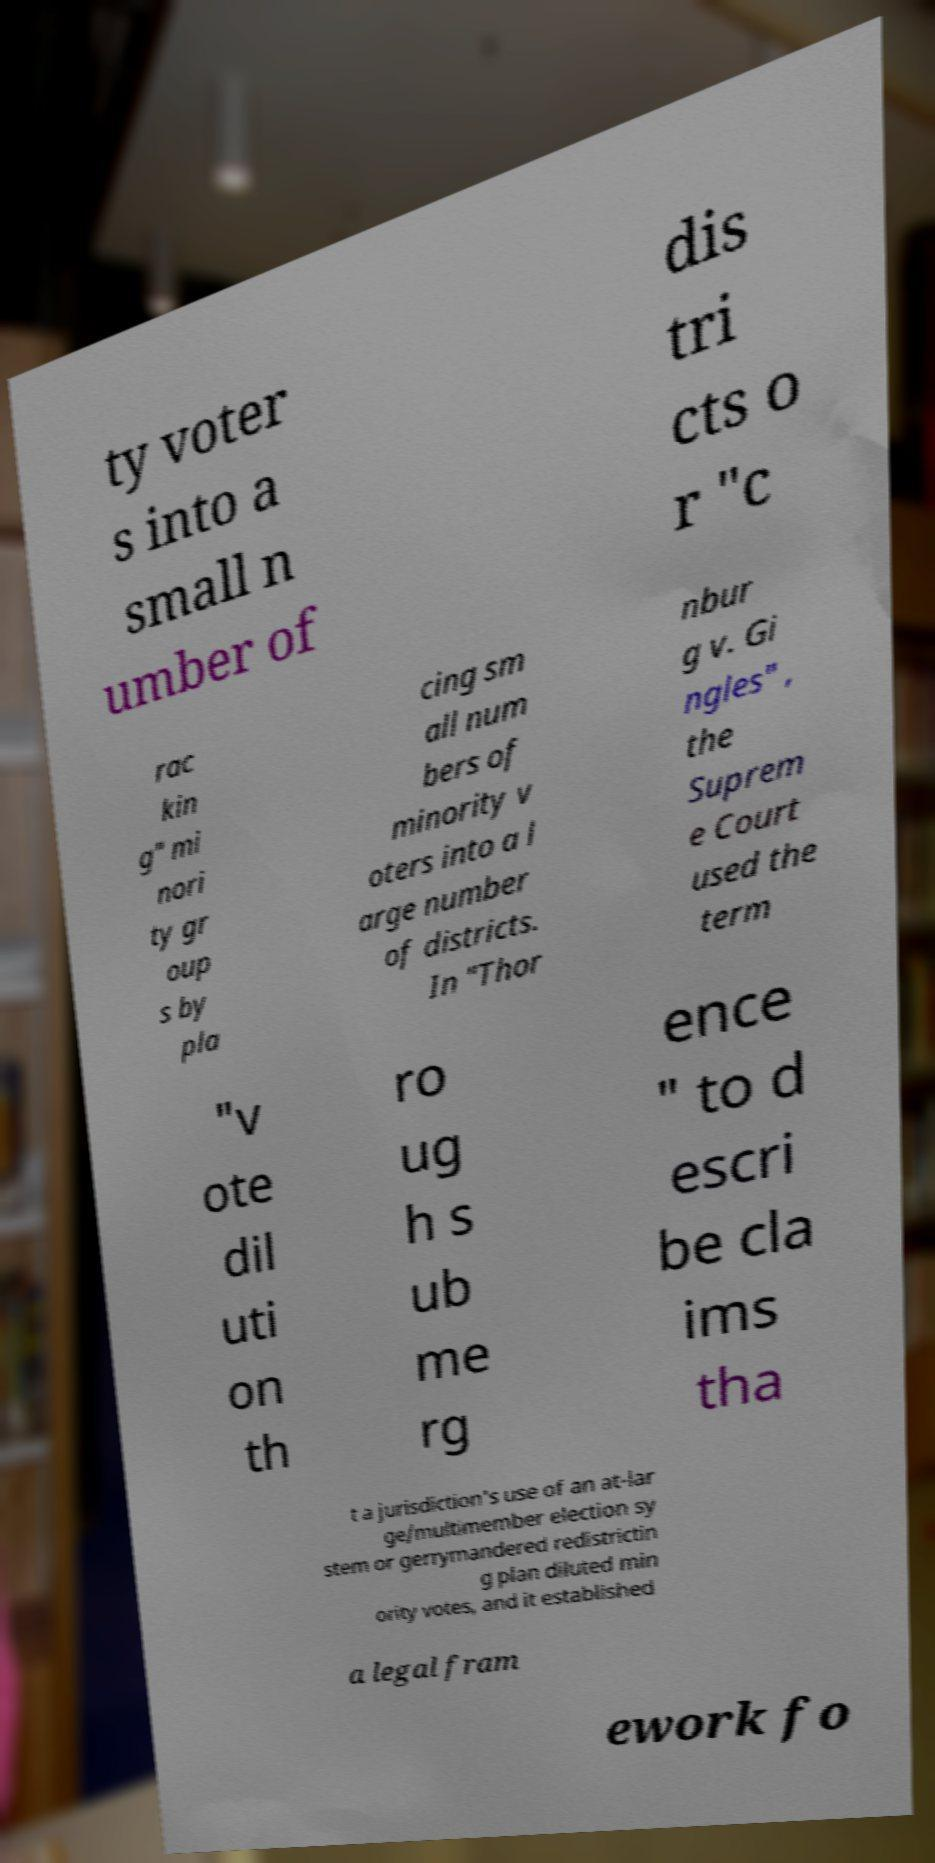Can you accurately transcribe the text from the provided image for me? ty voter s into a small n umber of dis tri cts o r "c rac kin g" mi nori ty gr oup s by pla cing sm all num bers of minority v oters into a l arge number of districts. In "Thor nbur g v. Gi ngles" , the Suprem e Court used the term "v ote dil uti on th ro ug h s ub me rg ence " to d escri be cla ims tha t a jurisdiction's use of an at-lar ge/multimember election sy stem or gerrymandered redistrictin g plan diluted min ority votes, and it established a legal fram ework fo 